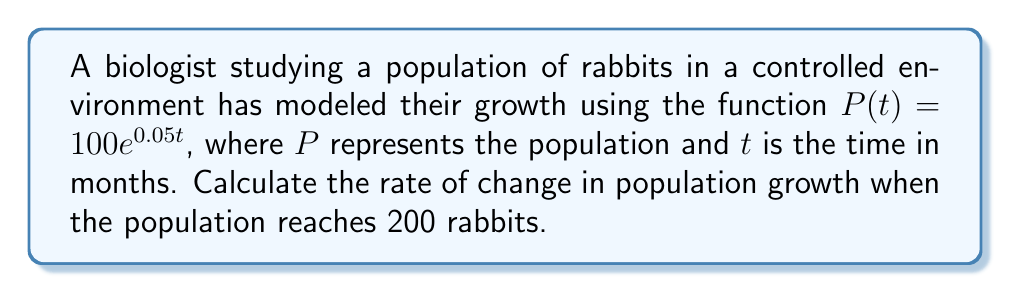Solve this math problem. 1) The rate of change in population growth is given by the derivative of $P(t)$ with respect to $t$. Let's find $\frac{dP}{dt}$:

   $$\frac{dP}{dt} = 100 \cdot 0.05e^{0.05t} = 5e^{0.05t}$$

2) We need to find $t$ when $P(t) = 200$:

   $$200 = 100e^{0.05t}$$
   $$2 = e^{0.05t}$$
   $$\ln 2 = 0.05t$$
   $$t = \frac{\ln 2}{0.05} \approx 13.86 \text{ months}$$

3) Now, we can substitute this value of $t$ into our derivative:

   $$\frac{dP}{dt} = 5e^{0.05(13.86)} = 5 \cdot 2 = 10$$

Therefore, when the population reaches 200 rabbits, it is growing at a rate of 10 rabbits per month.
Answer: 10 rabbits/month 